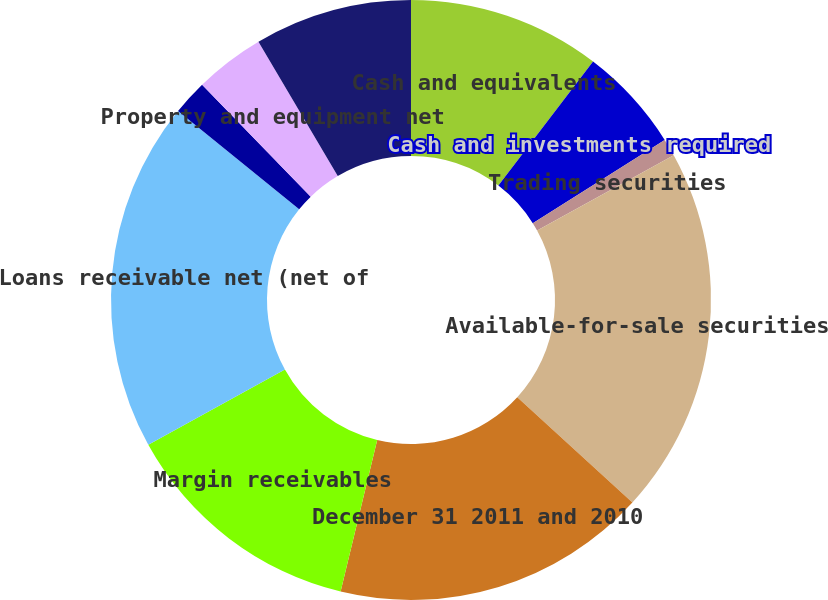Convert chart to OTSL. <chart><loc_0><loc_0><loc_500><loc_500><pie_chart><fcel>Cash and equivalents<fcel>Cash and investments required<fcel>Trading securities<fcel>Available-for-sale securities<fcel>December 31 2011 and 2010<fcel>Margin receivables<fcel>Loans receivable net (net of<fcel>Investment in FHLB stock<fcel>Property and equipment net<fcel>Goodwill<nl><fcel>10.38%<fcel>5.66%<fcel>0.94%<fcel>19.81%<fcel>16.98%<fcel>13.21%<fcel>18.87%<fcel>1.89%<fcel>3.77%<fcel>8.49%<nl></chart> 